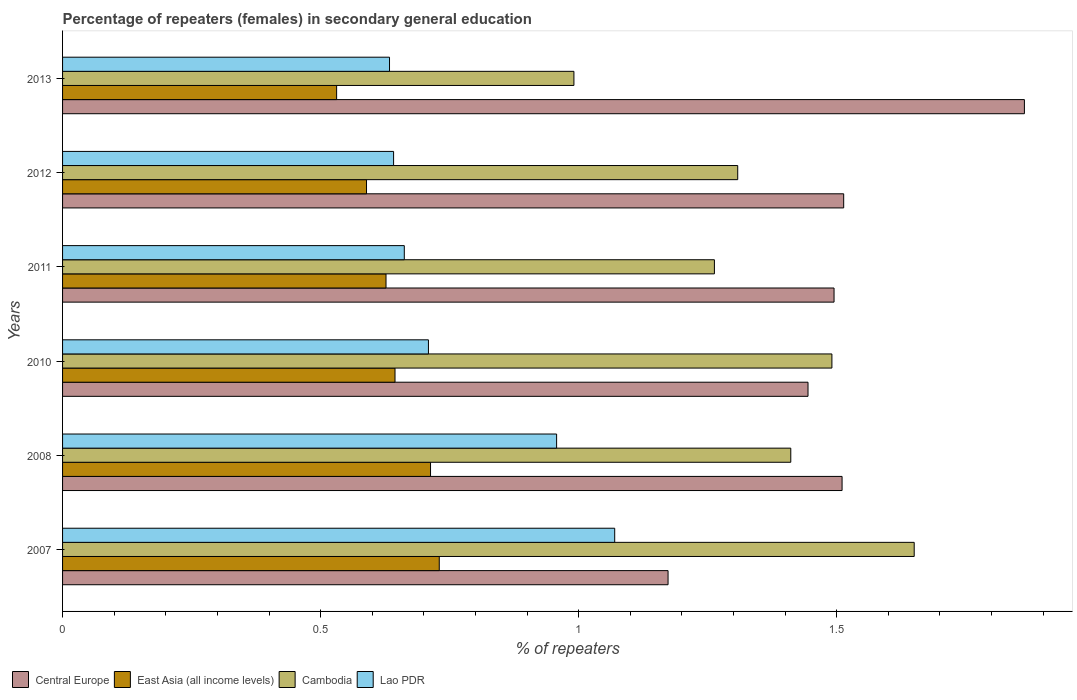How many different coloured bars are there?
Keep it short and to the point. 4. Are the number of bars on each tick of the Y-axis equal?
Offer a very short reply. Yes. How many bars are there on the 6th tick from the top?
Your response must be concise. 4. What is the label of the 2nd group of bars from the top?
Offer a very short reply. 2012. What is the percentage of female repeaters in Cambodia in 2012?
Provide a succinct answer. 1.31. Across all years, what is the maximum percentage of female repeaters in Lao PDR?
Give a very brief answer. 1.07. Across all years, what is the minimum percentage of female repeaters in Cambodia?
Offer a very short reply. 0.99. What is the total percentage of female repeaters in East Asia (all income levels) in the graph?
Your response must be concise. 3.83. What is the difference between the percentage of female repeaters in East Asia (all income levels) in 2010 and that in 2012?
Make the answer very short. 0.06. What is the difference between the percentage of female repeaters in Central Europe in 2008 and the percentage of female repeaters in Cambodia in 2013?
Your response must be concise. 0.52. What is the average percentage of female repeaters in Central Europe per year?
Your answer should be compact. 1.5. In the year 2012, what is the difference between the percentage of female repeaters in Lao PDR and percentage of female repeaters in Central Europe?
Keep it short and to the point. -0.87. What is the ratio of the percentage of female repeaters in Cambodia in 2008 to that in 2011?
Keep it short and to the point. 1.12. What is the difference between the highest and the second highest percentage of female repeaters in Cambodia?
Your answer should be compact. 0.16. What is the difference between the highest and the lowest percentage of female repeaters in Central Europe?
Offer a very short reply. 0.69. Is the sum of the percentage of female repeaters in Cambodia in 2010 and 2012 greater than the maximum percentage of female repeaters in Central Europe across all years?
Offer a very short reply. Yes. Is it the case that in every year, the sum of the percentage of female repeaters in Central Europe and percentage of female repeaters in Cambodia is greater than the sum of percentage of female repeaters in East Asia (all income levels) and percentage of female repeaters in Lao PDR?
Your answer should be very brief. No. What does the 4th bar from the top in 2008 represents?
Make the answer very short. Central Europe. What does the 4th bar from the bottom in 2007 represents?
Keep it short and to the point. Lao PDR. Is it the case that in every year, the sum of the percentage of female repeaters in Cambodia and percentage of female repeaters in East Asia (all income levels) is greater than the percentage of female repeaters in Lao PDR?
Provide a succinct answer. Yes. Are all the bars in the graph horizontal?
Keep it short and to the point. Yes. How many years are there in the graph?
Your answer should be very brief. 6. What is the difference between two consecutive major ticks on the X-axis?
Give a very brief answer. 0.5. Does the graph contain grids?
Keep it short and to the point. No. Where does the legend appear in the graph?
Provide a short and direct response. Bottom left. How many legend labels are there?
Offer a very short reply. 4. What is the title of the graph?
Ensure brevity in your answer.  Percentage of repeaters (females) in secondary general education. Does "Aruba" appear as one of the legend labels in the graph?
Your answer should be compact. No. What is the label or title of the X-axis?
Keep it short and to the point. % of repeaters. What is the label or title of the Y-axis?
Provide a short and direct response. Years. What is the % of repeaters in Central Europe in 2007?
Your answer should be compact. 1.17. What is the % of repeaters of East Asia (all income levels) in 2007?
Make the answer very short. 0.73. What is the % of repeaters of Cambodia in 2007?
Your response must be concise. 1.65. What is the % of repeaters of Lao PDR in 2007?
Your answer should be compact. 1.07. What is the % of repeaters of Central Europe in 2008?
Ensure brevity in your answer.  1.51. What is the % of repeaters in East Asia (all income levels) in 2008?
Keep it short and to the point. 0.71. What is the % of repeaters of Cambodia in 2008?
Offer a terse response. 1.41. What is the % of repeaters in Lao PDR in 2008?
Give a very brief answer. 0.96. What is the % of repeaters in Central Europe in 2010?
Make the answer very short. 1.44. What is the % of repeaters of East Asia (all income levels) in 2010?
Your answer should be compact. 0.64. What is the % of repeaters of Cambodia in 2010?
Give a very brief answer. 1.49. What is the % of repeaters of Lao PDR in 2010?
Make the answer very short. 0.71. What is the % of repeaters of Central Europe in 2011?
Your answer should be compact. 1.49. What is the % of repeaters of East Asia (all income levels) in 2011?
Provide a succinct answer. 0.63. What is the % of repeaters in Cambodia in 2011?
Give a very brief answer. 1.26. What is the % of repeaters of Lao PDR in 2011?
Give a very brief answer. 0.66. What is the % of repeaters in Central Europe in 2012?
Your response must be concise. 1.51. What is the % of repeaters of East Asia (all income levels) in 2012?
Your response must be concise. 0.59. What is the % of repeaters in Cambodia in 2012?
Offer a very short reply. 1.31. What is the % of repeaters of Lao PDR in 2012?
Keep it short and to the point. 0.64. What is the % of repeaters in Central Europe in 2013?
Provide a short and direct response. 1.86. What is the % of repeaters in East Asia (all income levels) in 2013?
Keep it short and to the point. 0.53. What is the % of repeaters of Cambodia in 2013?
Your answer should be compact. 0.99. What is the % of repeaters in Lao PDR in 2013?
Offer a very short reply. 0.63. Across all years, what is the maximum % of repeaters of Central Europe?
Give a very brief answer. 1.86. Across all years, what is the maximum % of repeaters in East Asia (all income levels)?
Ensure brevity in your answer.  0.73. Across all years, what is the maximum % of repeaters in Cambodia?
Give a very brief answer. 1.65. Across all years, what is the maximum % of repeaters of Lao PDR?
Make the answer very short. 1.07. Across all years, what is the minimum % of repeaters of Central Europe?
Offer a very short reply. 1.17. Across all years, what is the minimum % of repeaters in East Asia (all income levels)?
Ensure brevity in your answer.  0.53. Across all years, what is the minimum % of repeaters of Cambodia?
Offer a terse response. 0.99. Across all years, what is the minimum % of repeaters of Lao PDR?
Give a very brief answer. 0.63. What is the total % of repeaters in Central Europe in the graph?
Your response must be concise. 9. What is the total % of repeaters in East Asia (all income levels) in the graph?
Your answer should be compact. 3.83. What is the total % of repeaters of Cambodia in the graph?
Provide a succinct answer. 8.11. What is the total % of repeaters of Lao PDR in the graph?
Your answer should be very brief. 4.67. What is the difference between the % of repeaters in Central Europe in 2007 and that in 2008?
Your answer should be compact. -0.34. What is the difference between the % of repeaters in East Asia (all income levels) in 2007 and that in 2008?
Give a very brief answer. 0.02. What is the difference between the % of repeaters of Cambodia in 2007 and that in 2008?
Your answer should be compact. 0.24. What is the difference between the % of repeaters of Lao PDR in 2007 and that in 2008?
Provide a succinct answer. 0.11. What is the difference between the % of repeaters of Central Europe in 2007 and that in 2010?
Provide a succinct answer. -0.27. What is the difference between the % of repeaters in East Asia (all income levels) in 2007 and that in 2010?
Your response must be concise. 0.09. What is the difference between the % of repeaters of Cambodia in 2007 and that in 2010?
Keep it short and to the point. 0.16. What is the difference between the % of repeaters in Lao PDR in 2007 and that in 2010?
Give a very brief answer. 0.36. What is the difference between the % of repeaters of Central Europe in 2007 and that in 2011?
Ensure brevity in your answer.  -0.32. What is the difference between the % of repeaters in East Asia (all income levels) in 2007 and that in 2011?
Provide a short and direct response. 0.1. What is the difference between the % of repeaters in Cambodia in 2007 and that in 2011?
Your response must be concise. 0.39. What is the difference between the % of repeaters in Lao PDR in 2007 and that in 2011?
Provide a succinct answer. 0.41. What is the difference between the % of repeaters in Central Europe in 2007 and that in 2012?
Ensure brevity in your answer.  -0.34. What is the difference between the % of repeaters in East Asia (all income levels) in 2007 and that in 2012?
Keep it short and to the point. 0.14. What is the difference between the % of repeaters of Cambodia in 2007 and that in 2012?
Your response must be concise. 0.34. What is the difference between the % of repeaters in Lao PDR in 2007 and that in 2012?
Ensure brevity in your answer.  0.43. What is the difference between the % of repeaters of Central Europe in 2007 and that in 2013?
Give a very brief answer. -0.69. What is the difference between the % of repeaters in East Asia (all income levels) in 2007 and that in 2013?
Ensure brevity in your answer.  0.2. What is the difference between the % of repeaters of Cambodia in 2007 and that in 2013?
Your response must be concise. 0.66. What is the difference between the % of repeaters of Lao PDR in 2007 and that in 2013?
Your answer should be very brief. 0.44. What is the difference between the % of repeaters of Central Europe in 2008 and that in 2010?
Give a very brief answer. 0.07. What is the difference between the % of repeaters of East Asia (all income levels) in 2008 and that in 2010?
Provide a short and direct response. 0.07. What is the difference between the % of repeaters of Cambodia in 2008 and that in 2010?
Provide a short and direct response. -0.08. What is the difference between the % of repeaters of Lao PDR in 2008 and that in 2010?
Make the answer very short. 0.25. What is the difference between the % of repeaters in Central Europe in 2008 and that in 2011?
Offer a terse response. 0.02. What is the difference between the % of repeaters of East Asia (all income levels) in 2008 and that in 2011?
Your answer should be compact. 0.09. What is the difference between the % of repeaters of Cambodia in 2008 and that in 2011?
Provide a succinct answer. 0.15. What is the difference between the % of repeaters of Lao PDR in 2008 and that in 2011?
Offer a very short reply. 0.3. What is the difference between the % of repeaters of Central Europe in 2008 and that in 2012?
Ensure brevity in your answer.  -0. What is the difference between the % of repeaters in East Asia (all income levels) in 2008 and that in 2012?
Ensure brevity in your answer.  0.12. What is the difference between the % of repeaters in Cambodia in 2008 and that in 2012?
Offer a terse response. 0.1. What is the difference between the % of repeaters in Lao PDR in 2008 and that in 2012?
Provide a succinct answer. 0.32. What is the difference between the % of repeaters in Central Europe in 2008 and that in 2013?
Make the answer very short. -0.35. What is the difference between the % of repeaters of East Asia (all income levels) in 2008 and that in 2013?
Your response must be concise. 0.18. What is the difference between the % of repeaters of Cambodia in 2008 and that in 2013?
Provide a succinct answer. 0.42. What is the difference between the % of repeaters in Lao PDR in 2008 and that in 2013?
Provide a succinct answer. 0.32. What is the difference between the % of repeaters in Central Europe in 2010 and that in 2011?
Offer a very short reply. -0.05. What is the difference between the % of repeaters of East Asia (all income levels) in 2010 and that in 2011?
Keep it short and to the point. 0.02. What is the difference between the % of repeaters of Cambodia in 2010 and that in 2011?
Provide a succinct answer. 0.23. What is the difference between the % of repeaters of Lao PDR in 2010 and that in 2011?
Offer a very short reply. 0.05. What is the difference between the % of repeaters of Central Europe in 2010 and that in 2012?
Give a very brief answer. -0.07. What is the difference between the % of repeaters of East Asia (all income levels) in 2010 and that in 2012?
Provide a short and direct response. 0.06. What is the difference between the % of repeaters in Cambodia in 2010 and that in 2012?
Provide a short and direct response. 0.18. What is the difference between the % of repeaters of Lao PDR in 2010 and that in 2012?
Ensure brevity in your answer.  0.07. What is the difference between the % of repeaters of Central Europe in 2010 and that in 2013?
Your response must be concise. -0.42. What is the difference between the % of repeaters of East Asia (all income levels) in 2010 and that in 2013?
Your response must be concise. 0.11. What is the difference between the % of repeaters of Cambodia in 2010 and that in 2013?
Provide a short and direct response. 0.5. What is the difference between the % of repeaters in Lao PDR in 2010 and that in 2013?
Give a very brief answer. 0.08. What is the difference between the % of repeaters in Central Europe in 2011 and that in 2012?
Your answer should be very brief. -0.02. What is the difference between the % of repeaters in East Asia (all income levels) in 2011 and that in 2012?
Make the answer very short. 0.04. What is the difference between the % of repeaters of Cambodia in 2011 and that in 2012?
Your answer should be compact. -0.05. What is the difference between the % of repeaters in Lao PDR in 2011 and that in 2012?
Provide a succinct answer. 0.02. What is the difference between the % of repeaters in Central Europe in 2011 and that in 2013?
Provide a short and direct response. -0.37. What is the difference between the % of repeaters in East Asia (all income levels) in 2011 and that in 2013?
Provide a succinct answer. 0.1. What is the difference between the % of repeaters of Cambodia in 2011 and that in 2013?
Your response must be concise. 0.27. What is the difference between the % of repeaters of Lao PDR in 2011 and that in 2013?
Make the answer very short. 0.03. What is the difference between the % of repeaters in Central Europe in 2012 and that in 2013?
Provide a succinct answer. -0.35. What is the difference between the % of repeaters in East Asia (all income levels) in 2012 and that in 2013?
Offer a very short reply. 0.06. What is the difference between the % of repeaters in Cambodia in 2012 and that in 2013?
Give a very brief answer. 0.32. What is the difference between the % of repeaters in Lao PDR in 2012 and that in 2013?
Offer a very short reply. 0.01. What is the difference between the % of repeaters of Central Europe in 2007 and the % of repeaters of East Asia (all income levels) in 2008?
Offer a very short reply. 0.46. What is the difference between the % of repeaters of Central Europe in 2007 and the % of repeaters of Cambodia in 2008?
Your answer should be compact. -0.24. What is the difference between the % of repeaters in Central Europe in 2007 and the % of repeaters in Lao PDR in 2008?
Make the answer very short. 0.22. What is the difference between the % of repeaters in East Asia (all income levels) in 2007 and the % of repeaters in Cambodia in 2008?
Your answer should be compact. -0.68. What is the difference between the % of repeaters in East Asia (all income levels) in 2007 and the % of repeaters in Lao PDR in 2008?
Make the answer very short. -0.23. What is the difference between the % of repeaters of Cambodia in 2007 and the % of repeaters of Lao PDR in 2008?
Ensure brevity in your answer.  0.69. What is the difference between the % of repeaters of Central Europe in 2007 and the % of repeaters of East Asia (all income levels) in 2010?
Your answer should be very brief. 0.53. What is the difference between the % of repeaters in Central Europe in 2007 and the % of repeaters in Cambodia in 2010?
Offer a very short reply. -0.32. What is the difference between the % of repeaters of Central Europe in 2007 and the % of repeaters of Lao PDR in 2010?
Provide a short and direct response. 0.46. What is the difference between the % of repeaters in East Asia (all income levels) in 2007 and the % of repeaters in Cambodia in 2010?
Make the answer very short. -0.76. What is the difference between the % of repeaters in East Asia (all income levels) in 2007 and the % of repeaters in Lao PDR in 2010?
Offer a very short reply. 0.02. What is the difference between the % of repeaters in Cambodia in 2007 and the % of repeaters in Lao PDR in 2010?
Provide a succinct answer. 0.94. What is the difference between the % of repeaters in Central Europe in 2007 and the % of repeaters in East Asia (all income levels) in 2011?
Your answer should be very brief. 0.55. What is the difference between the % of repeaters of Central Europe in 2007 and the % of repeaters of Cambodia in 2011?
Offer a terse response. -0.09. What is the difference between the % of repeaters in Central Europe in 2007 and the % of repeaters in Lao PDR in 2011?
Ensure brevity in your answer.  0.51. What is the difference between the % of repeaters in East Asia (all income levels) in 2007 and the % of repeaters in Cambodia in 2011?
Offer a very short reply. -0.53. What is the difference between the % of repeaters of East Asia (all income levels) in 2007 and the % of repeaters of Lao PDR in 2011?
Make the answer very short. 0.07. What is the difference between the % of repeaters of Cambodia in 2007 and the % of repeaters of Lao PDR in 2011?
Provide a succinct answer. 0.99. What is the difference between the % of repeaters of Central Europe in 2007 and the % of repeaters of East Asia (all income levels) in 2012?
Your answer should be very brief. 0.58. What is the difference between the % of repeaters of Central Europe in 2007 and the % of repeaters of Cambodia in 2012?
Offer a terse response. -0.14. What is the difference between the % of repeaters in Central Europe in 2007 and the % of repeaters in Lao PDR in 2012?
Your answer should be very brief. 0.53. What is the difference between the % of repeaters of East Asia (all income levels) in 2007 and the % of repeaters of Cambodia in 2012?
Offer a terse response. -0.58. What is the difference between the % of repeaters in East Asia (all income levels) in 2007 and the % of repeaters in Lao PDR in 2012?
Your answer should be compact. 0.09. What is the difference between the % of repeaters in Cambodia in 2007 and the % of repeaters in Lao PDR in 2012?
Offer a very short reply. 1.01. What is the difference between the % of repeaters of Central Europe in 2007 and the % of repeaters of East Asia (all income levels) in 2013?
Keep it short and to the point. 0.64. What is the difference between the % of repeaters of Central Europe in 2007 and the % of repeaters of Cambodia in 2013?
Give a very brief answer. 0.18. What is the difference between the % of repeaters in Central Europe in 2007 and the % of repeaters in Lao PDR in 2013?
Give a very brief answer. 0.54. What is the difference between the % of repeaters of East Asia (all income levels) in 2007 and the % of repeaters of Cambodia in 2013?
Keep it short and to the point. -0.26. What is the difference between the % of repeaters in East Asia (all income levels) in 2007 and the % of repeaters in Lao PDR in 2013?
Your answer should be very brief. 0.1. What is the difference between the % of repeaters in Cambodia in 2007 and the % of repeaters in Lao PDR in 2013?
Your answer should be compact. 1.02. What is the difference between the % of repeaters of Central Europe in 2008 and the % of repeaters of East Asia (all income levels) in 2010?
Your response must be concise. 0.87. What is the difference between the % of repeaters of Central Europe in 2008 and the % of repeaters of Cambodia in 2010?
Your response must be concise. 0.02. What is the difference between the % of repeaters of Central Europe in 2008 and the % of repeaters of Lao PDR in 2010?
Your answer should be compact. 0.8. What is the difference between the % of repeaters in East Asia (all income levels) in 2008 and the % of repeaters in Cambodia in 2010?
Your response must be concise. -0.78. What is the difference between the % of repeaters of East Asia (all income levels) in 2008 and the % of repeaters of Lao PDR in 2010?
Give a very brief answer. 0. What is the difference between the % of repeaters of Cambodia in 2008 and the % of repeaters of Lao PDR in 2010?
Your answer should be compact. 0.7. What is the difference between the % of repeaters in Central Europe in 2008 and the % of repeaters in East Asia (all income levels) in 2011?
Keep it short and to the point. 0.88. What is the difference between the % of repeaters of Central Europe in 2008 and the % of repeaters of Cambodia in 2011?
Your answer should be compact. 0.25. What is the difference between the % of repeaters in Central Europe in 2008 and the % of repeaters in Lao PDR in 2011?
Your response must be concise. 0.85. What is the difference between the % of repeaters of East Asia (all income levels) in 2008 and the % of repeaters of Cambodia in 2011?
Your answer should be very brief. -0.55. What is the difference between the % of repeaters of East Asia (all income levels) in 2008 and the % of repeaters of Lao PDR in 2011?
Ensure brevity in your answer.  0.05. What is the difference between the % of repeaters of Cambodia in 2008 and the % of repeaters of Lao PDR in 2011?
Make the answer very short. 0.75. What is the difference between the % of repeaters in Central Europe in 2008 and the % of repeaters in East Asia (all income levels) in 2012?
Offer a very short reply. 0.92. What is the difference between the % of repeaters of Central Europe in 2008 and the % of repeaters of Cambodia in 2012?
Your answer should be compact. 0.2. What is the difference between the % of repeaters of Central Europe in 2008 and the % of repeaters of Lao PDR in 2012?
Give a very brief answer. 0.87. What is the difference between the % of repeaters in East Asia (all income levels) in 2008 and the % of repeaters in Cambodia in 2012?
Your answer should be very brief. -0.6. What is the difference between the % of repeaters of East Asia (all income levels) in 2008 and the % of repeaters of Lao PDR in 2012?
Keep it short and to the point. 0.07. What is the difference between the % of repeaters in Cambodia in 2008 and the % of repeaters in Lao PDR in 2012?
Give a very brief answer. 0.77. What is the difference between the % of repeaters of Central Europe in 2008 and the % of repeaters of East Asia (all income levels) in 2013?
Offer a very short reply. 0.98. What is the difference between the % of repeaters of Central Europe in 2008 and the % of repeaters of Cambodia in 2013?
Provide a succinct answer. 0.52. What is the difference between the % of repeaters of Central Europe in 2008 and the % of repeaters of Lao PDR in 2013?
Provide a succinct answer. 0.88. What is the difference between the % of repeaters of East Asia (all income levels) in 2008 and the % of repeaters of Cambodia in 2013?
Offer a very short reply. -0.28. What is the difference between the % of repeaters of East Asia (all income levels) in 2008 and the % of repeaters of Lao PDR in 2013?
Your answer should be very brief. 0.08. What is the difference between the % of repeaters of Cambodia in 2008 and the % of repeaters of Lao PDR in 2013?
Make the answer very short. 0.78. What is the difference between the % of repeaters in Central Europe in 2010 and the % of repeaters in East Asia (all income levels) in 2011?
Ensure brevity in your answer.  0.82. What is the difference between the % of repeaters of Central Europe in 2010 and the % of repeaters of Cambodia in 2011?
Make the answer very short. 0.18. What is the difference between the % of repeaters of Central Europe in 2010 and the % of repeaters of Lao PDR in 2011?
Give a very brief answer. 0.78. What is the difference between the % of repeaters of East Asia (all income levels) in 2010 and the % of repeaters of Cambodia in 2011?
Ensure brevity in your answer.  -0.62. What is the difference between the % of repeaters of East Asia (all income levels) in 2010 and the % of repeaters of Lao PDR in 2011?
Make the answer very short. -0.02. What is the difference between the % of repeaters in Cambodia in 2010 and the % of repeaters in Lao PDR in 2011?
Give a very brief answer. 0.83. What is the difference between the % of repeaters in Central Europe in 2010 and the % of repeaters in East Asia (all income levels) in 2012?
Your response must be concise. 0.86. What is the difference between the % of repeaters of Central Europe in 2010 and the % of repeaters of Cambodia in 2012?
Provide a succinct answer. 0.14. What is the difference between the % of repeaters in Central Europe in 2010 and the % of repeaters in Lao PDR in 2012?
Make the answer very short. 0.8. What is the difference between the % of repeaters in East Asia (all income levels) in 2010 and the % of repeaters in Cambodia in 2012?
Give a very brief answer. -0.66. What is the difference between the % of repeaters of East Asia (all income levels) in 2010 and the % of repeaters of Lao PDR in 2012?
Your response must be concise. 0. What is the difference between the % of repeaters of Cambodia in 2010 and the % of repeaters of Lao PDR in 2012?
Keep it short and to the point. 0.85. What is the difference between the % of repeaters of Central Europe in 2010 and the % of repeaters of East Asia (all income levels) in 2013?
Offer a terse response. 0.91. What is the difference between the % of repeaters in Central Europe in 2010 and the % of repeaters in Cambodia in 2013?
Your answer should be compact. 0.45. What is the difference between the % of repeaters of Central Europe in 2010 and the % of repeaters of Lao PDR in 2013?
Your answer should be compact. 0.81. What is the difference between the % of repeaters of East Asia (all income levels) in 2010 and the % of repeaters of Cambodia in 2013?
Make the answer very short. -0.35. What is the difference between the % of repeaters of East Asia (all income levels) in 2010 and the % of repeaters of Lao PDR in 2013?
Make the answer very short. 0.01. What is the difference between the % of repeaters in Cambodia in 2010 and the % of repeaters in Lao PDR in 2013?
Your answer should be compact. 0.86. What is the difference between the % of repeaters in Central Europe in 2011 and the % of repeaters in East Asia (all income levels) in 2012?
Offer a terse response. 0.91. What is the difference between the % of repeaters of Central Europe in 2011 and the % of repeaters of Cambodia in 2012?
Give a very brief answer. 0.19. What is the difference between the % of repeaters of Central Europe in 2011 and the % of repeaters of Lao PDR in 2012?
Provide a succinct answer. 0.85. What is the difference between the % of repeaters in East Asia (all income levels) in 2011 and the % of repeaters in Cambodia in 2012?
Offer a very short reply. -0.68. What is the difference between the % of repeaters of East Asia (all income levels) in 2011 and the % of repeaters of Lao PDR in 2012?
Ensure brevity in your answer.  -0.01. What is the difference between the % of repeaters of Cambodia in 2011 and the % of repeaters of Lao PDR in 2012?
Ensure brevity in your answer.  0.62. What is the difference between the % of repeaters in Central Europe in 2011 and the % of repeaters in East Asia (all income levels) in 2013?
Provide a succinct answer. 0.96. What is the difference between the % of repeaters of Central Europe in 2011 and the % of repeaters of Cambodia in 2013?
Make the answer very short. 0.5. What is the difference between the % of repeaters of Central Europe in 2011 and the % of repeaters of Lao PDR in 2013?
Keep it short and to the point. 0.86. What is the difference between the % of repeaters of East Asia (all income levels) in 2011 and the % of repeaters of Cambodia in 2013?
Provide a short and direct response. -0.36. What is the difference between the % of repeaters in East Asia (all income levels) in 2011 and the % of repeaters in Lao PDR in 2013?
Your answer should be compact. -0.01. What is the difference between the % of repeaters of Cambodia in 2011 and the % of repeaters of Lao PDR in 2013?
Offer a terse response. 0.63. What is the difference between the % of repeaters of Central Europe in 2012 and the % of repeaters of East Asia (all income levels) in 2013?
Ensure brevity in your answer.  0.98. What is the difference between the % of repeaters of Central Europe in 2012 and the % of repeaters of Cambodia in 2013?
Provide a succinct answer. 0.52. What is the difference between the % of repeaters in East Asia (all income levels) in 2012 and the % of repeaters in Cambodia in 2013?
Offer a very short reply. -0.4. What is the difference between the % of repeaters in East Asia (all income levels) in 2012 and the % of repeaters in Lao PDR in 2013?
Offer a terse response. -0.04. What is the difference between the % of repeaters in Cambodia in 2012 and the % of repeaters in Lao PDR in 2013?
Your answer should be compact. 0.67. What is the average % of repeaters in Central Europe per year?
Offer a terse response. 1.5. What is the average % of repeaters in East Asia (all income levels) per year?
Provide a succinct answer. 0.64. What is the average % of repeaters of Cambodia per year?
Keep it short and to the point. 1.35. What is the average % of repeaters in Lao PDR per year?
Your response must be concise. 0.78. In the year 2007, what is the difference between the % of repeaters in Central Europe and % of repeaters in East Asia (all income levels)?
Ensure brevity in your answer.  0.44. In the year 2007, what is the difference between the % of repeaters of Central Europe and % of repeaters of Cambodia?
Provide a short and direct response. -0.48. In the year 2007, what is the difference between the % of repeaters in Central Europe and % of repeaters in Lao PDR?
Your answer should be very brief. 0.1. In the year 2007, what is the difference between the % of repeaters of East Asia (all income levels) and % of repeaters of Cambodia?
Ensure brevity in your answer.  -0.92. In the year 2007, what is the difference between the % of repeaters in East Asia (all income levels) and % of repeaters in Lao PDR?
Make the answer very short. -0.34. In the year 2007, what is the difference between the % of repeaters of Cambodia and % of repeaters of Lao PDR?
Keep it short and to the point. 0.58. In the year 2008, what is the difference between the % of repeaters of Central Europe and % of repeaters of East Asia (all income levels)?
Your response must be concise. 0.8. In the year 2008, what is the difference between the % of repeaters of Central Europe and % of repeaters of Cambodia?
Your answer should be very brief. 0.1. In the year 2008, what is the difference between the % of repeaters in Central Europe and % of repeaters in Lao PDR?
Your response must be concise. 0.55. In the year 2008, what is the difference between the % of repeaters of East Asia (all income levels) and % of repeaters of Cambodia?
Make the answer very short. -0.7. In the year 2008, what is the difference between the % of repeaters in East Asia (all income levels) and % of repeaters in Lao PDR?
Offer a very short reply. -0.24. In the year 2008, what is the difference between the % of repeaters in Cambodia and % of repeaters in Lao PDR?
Provide a succinct answer. 0.45. In the year 2010, what is the difference between the % of repeaters of Central Europe and % of repeaters of East Asia (all income levels)?
Your answer should be compact. 0.8. In the year 2010, what is the difference between the % of repeaters in Central Europe and % of repeaters in Cambodia?
Give a very brief answer. -0.05. In the year 2010, what is the difference between the % of repeaters in Central Europe and % of repeaters in Lao PDR?
Your response must be concise. 0.74. In the year 2010, what is the difference between the % of repeaters in East Asia (all income levels) and % of repeaters in Cambodia?
Provide a succinct answer. -0.85. In the year 2010, what is the difference between the % of repeaters of East Asia (all income levels) and % of repeaters of Lao PDR?
Your answer should be very brief. -0.06. In the year 2010, what is the difference between the % of repeaters in Cambodia and % of repeaters in Lao PDR?
Your answer should be compact. 0.78. In the year 2011, what is the difference between the % of repeaters in Central Europe and % of repeaters in East Asia (all income levels)?
Your response must be concise. 0.87. In the year 2011, what is the difference between the % of repeaters in Central Europe and % of repeaters in Cambodia?
Keep it short and to the point. 0.23. In the year 2011, what is the difference between the % of repeaters of Central Europe and % of repeaters of Lao PDR?
Provide a short and direct response. 0.83. In the year 2011, what is the difference between the % of repeaters in East Asia (all income levels) and % of repeaters in Cambodia?
Ensure brevity in your answer.  -0.64. In the year 2011, what is the difference between the % of repeaters of East Asia (all income levels) and % of repeaters of Lao PDR?
Your answer should be very brief. -0.04. In the year 2011, what is the difference between the % of repeaters in Cambodia and % of repeaters in Lao PDR?
Ensure brevity in your answer.  0.6. In the year 2012, what is the difference between the % of repeaters in Central Europe and % of repeaters in East Asia (all income levels)?
Your response must be concise. 0.92. In the year 2012, what is the difference between the % of repeaters in Central Europe and % of repeaters in Cambodia?
Your answer should be compact. 0.21. In the year 2012, what is the difference between the % of repeaters of Central Europe and % of repeaters of Lao PDR?
Give a very brief answer. 0.87. In the year 2012, what is the difference between the % of repeaters in East Asia (all income levels) and % of repeaters in Cambodia?
Keep it short and to the point. -0.72. In the year 2012, what is the difference between the % of repeaters of East Asia (all income levels) and % of repeaters of Lao PDR?
Provide a succinct answer. -0.05. In the year 2012, what is the difference between the % of repeaters in Cambodia and % of repeaters in Lao PDR?
Make the answer very short. 0.67. In the year 2013, what is the difference between the % of repeaters in Central Europe and % of repeaters in East Asia (all income levels)?
Provide a short and direct response. 1.33. In the year 2013, what is the difference between the % of repeaters in Central Europe and % of repeaters in Cambodia?
Your answer should be compact. 0.87. In the year 2013, what is the difference between the % of repeaters of Central Europe and % of repeaters of Lao PDR?
Offer a terse response. 1.23. In the year 2013, what is the difference between the % of repeaters in East Asia (all income levels) and % of repeaters in Cambodia?
Offer a terse response. -0.46. In the year 2013, what is the difference between the % of repeaters in East Asia (all income levels) and % of repeaters in Lao PDR?
Keep it short and to the point. -0.1. In the year 2013, what is the difference between the % of repeaters of Cambodia and % of repeaters of Lao PDR?
Your answer should be compact. 0.36. What is the ratio of the % of repeaters in Central Europe in 2007 to that in 2008?
Your response must be concise. 0.78. What is the ratio of the % of repeaters of East Asia (all income levels) in 2007 to that in 2008?
Provide a short and direct response. 1.02. What is the ratio of the % of repeaters of Cambodia in 2007 to that in 2008?
Your answer should be compact. 1.17. What is the ratio of the % of repeaters in Lao PDR in 2007 to that in 2008?
Your response must be concise. 1.12. What is the ratio of the % of repeaters of Central Europe in 2007 to that in 2010?
Provide a short and direct response. 0.81. What is the ratio of the % of repeaters of East Asia (all income levels) in 2007 to that in 2010?
Make the answer very short. 1.13. What is the ratio of the % of repeaters of Cambodia in 2007 to that in 2010?
Make the answer very short. 1.11. What is the ratio of the % of repeaters of Lao PDR in 2007 to that in 2010?
Ensure brevity in your answer.  1.51. What is the ratio of the % of repeaters in Central Europe in 2007 to that in 2011?
Offer a very short reply. 0.78. What is the ratio of the % of repeaters of East Asia (all income levels) in 2007 to that in 2011?
Provide a short and direct response. 1.16. What is the ratio of the % of repeaters of Cambodia in 2007 to that in 2011?
Make the answer very short. 1.31. What is the ratio of the % of repeaters in Lao PDR in 2007 to that in 2011?
Keep it short and to the point. 1.62. What is the ratio of the % of repeaters of Central Europe in 2007 to that in 2012?
Make the answer very short. 0.78. What is the ratio of the % of repeaters in East Asia (all income levels) in 2007 to that in 2012?
Provide a short and direct response. 1.24. What is the ratio of the % of repeaters in Cambodia in 2007 to that in 2012?
Offer a very short reply. 1.26. What is the ratio of the % of repeaters in Lao PDR in 2007 to that in 2012?
Your answer should be very brief. 1.67. What is the ratio of the % of repeaters in Central Europe in 2007 to that in 2013?
Offer a very short reply. 0.63. What is the ratio of the % of repeaters in East Asia (all income levels) in 2007 to that in 2013?
Ensure brevity in your answer.  1.37. What is the ratio of the % of repeaters in Cambodia in 2007 to that in 2013?
Ensure brevity in your answer.  1.67. What is the ratio of the % of repeaters in Lao PDR in 2007 to that in 2013?
Your answer should be very brief. 1.69. What is the ratio of the % of repeaters of Central Europe in 2008 to that in 2010?
Make the answer very short. 1.05. What is the ratio of the % of repeaters in East Asia (all income levels) in 2008 to that in 2010?
Your response must be concise. 1.11. What is the ratio of the % of repeaters in Cambodia in 2008 to that in 2010?
Provide a short and direct response. 0.95. What is the ratio of the % of repeaters of Lao PDR in 2008 to that in 2010?
Provide a short and direct response. 1.35. What is the ratio of the % of repeaters of Central Europe in 2008 to that in 2011?
Offer a very short reply. 1.01. What is the ratio of the % of repeaters in East Asia (all income levels) in 2008 to that in 2011?
Provide a short and direct response. 1.14. What is the ratio of the % of repeaters in Cambodia in 2008 to that in 2011?
Offer a very short reply. 1.12. What is the ratio of the % of repeaters in Lao PDR in 2008 to that in 2011?
Ensure brevity in your answer.  1.45. What is the ratio of the % of repeaters of Central Europe in 2008 to that in 2012?
Your response must be concise. 1. What is the ratio of the % of repeaters in East Asia (all income levels) in 2008 to that in 2012?
Provide a succinct answer. 1.21. What is the ratio of the % of repeaters of Cambodia in 2008 to that in 2012?
Keep it short and to the point. 1.08. What is the ratio of the % of repeaters in Lao PDR in 2008 to that in 2012?
Make the answer very short. 1.49. What is the ratio of the % of repeaters of Central Europe in 2008 to that in 2013?
Offer a very short reply. 0.81. What is the ratio of the % of repeaters in East Asia (all income levels) in 2008 to that in 2013?
Keep it short and to the point. 1.34. What is the ratio of the % of repeaters of Cambodia in 2008 to that in 2013?
Make the answer very short. 1.42. What is the ratio of the % of repeaters in Lao PDR in 2008 to that in 2013?
Keep it short and to the point. 1.51. What is the ratio of the % of repeaters of Central Europe in 2010 to that in 2011?
Provide a succinct answer. 0.97. What is the ratio of the % of repeaters in East Asia (all income levels) in 2010 to that in 2011?
Provide a short and direct response. 1.03. What is the ratio of the % of repeaters in Cambodia in 2010 to that in 2011?
Make the answer very short. 1.18. What is the ratio of the % of repeaters in Lao PDR in 2010 to that in 2011?
Keep it short and to the point. 1.07. What is the ratio of the % of repeaters of Central Europe in 2010 to that in 2012?
Keep it short and to the point. 0.95. What is the ratio of the % of repeaters of East Asia (all income levels) in 2010 to that in 2012?
Provide a short and direct response. 1.09. What is the ratio of the % of repeaters in Cambodia in 2010 to that in 2012?
Offer a very short reply. 1.14. What is the ratio of the % of repeaters in Lao PDR in 2010 to that in 2012?
Your answer should be compact. 1.11. What is the ratio of the % of repeaters of Central Europe in 2010 to that in 2013?
Your answer should be very brief. 0.78. What is the ratio of the % of repeaters of East Asia (all income levels) in 2010 to that in 2013?
Make the answer very short. 1.21. What is the ratio of the % of repeaters of Cambodia in 2010 to that in 2013?
Provide a succinct answer. 1.5. What is the ratio of the % of repeaters of Lao PDR in 2010 to that in 2013?
Give a very brief answer. 1.12. What is the ratio of the % of repeaters of East Asia (all income levels) in 2011 to that in 2012?
Offer a very short reply. 1.06. What is the ratio of the % of repeaters in Cambodia in 2011 to that in 2012?
Offer a very short reply. 0.97. What is the ratio of the % of repeaters in Lao PDR in 2011 to that in 2012?
Keep it short and to the point. 1.03. What is the ratio of the % of repeaters of Central Europe in 2011 to that in 2013?
Make the answer very short. 0.8. What is the ratio of the % of repeaters in East Asia (all income levels) in 2011 to that in 2013?
Ensure brevity in your answer.  1.18. What is the ratio of the % of repeaters in Cambodia in 2011 to that in 2013?
Offer a terse response. 1.27. What is the ratio of the % of repeaters of Lao PDR in 2011 to that in 2013?
Offer a very short reply. 1.05. What is the ratio of the % of repeaters in Central Europe in 2012 to that in 2013?
Provide a short and direct response. 0.81. What is the ratio of the % of repeaters of East Asia (all income levels) in 2012 to that in 2013?
Offer a very short reply. 1.11. What is the ratio of the % of repeaters of Cambodia in 2012 to that in 2013?
Provide a short and direct response. 1.32. What is the ratio of the % of repeaters of Lao PDR in 2012 to that in 2013?
Offer a very short reply. 1.01. What is the difference between the highest and the second highest % of repeaters of Central Europe?
Ensure brevity in your answer.  0.35. What is the difference between the highest and the second highest % of repeaters of East Asia (all income levels)?
Provide a short and direct response. 0.02. What is the difference between the highest and the second highest % of repeaters in Cambodia?
Keep it short and to the point. 0.16. What is the difference between the highest and the second highest % of repeaters of Lao PDR?
Offer a very short reply. 0.11. What is the difference between the highest and the lowest % of repeaters in Central Europe?
Provide a succinct answer. 0.69. What is the difference between the highest and the lowest % of repeaters of East Asia (all income levels)?
Keep it short and to the point. 0.2. What is the difference between the highest and the lowest % of repeaters of Cambodia?
Offer a terse response. 0.66. What is the difference between the highest and the lowest % of repeaters of Lao PDR?
Provide a succinct answer. 0.44. 